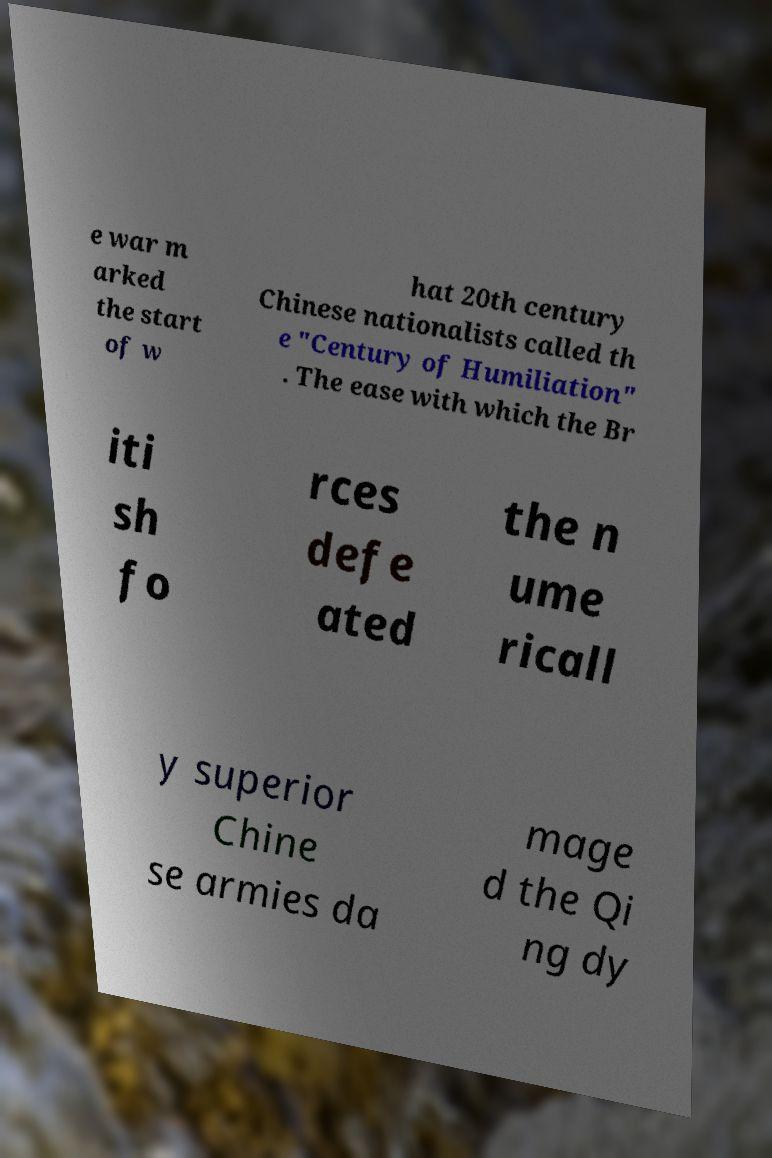Please identify and transcribe the text found in this image. e war m arked the start of w hat 20th century Chinese nationalists called th e "Century of Humiliation" . The ease with which the Br iti sh fo rces defe ated the n ume ricall y superior Chine se armies da mage d the Qi ng dy 